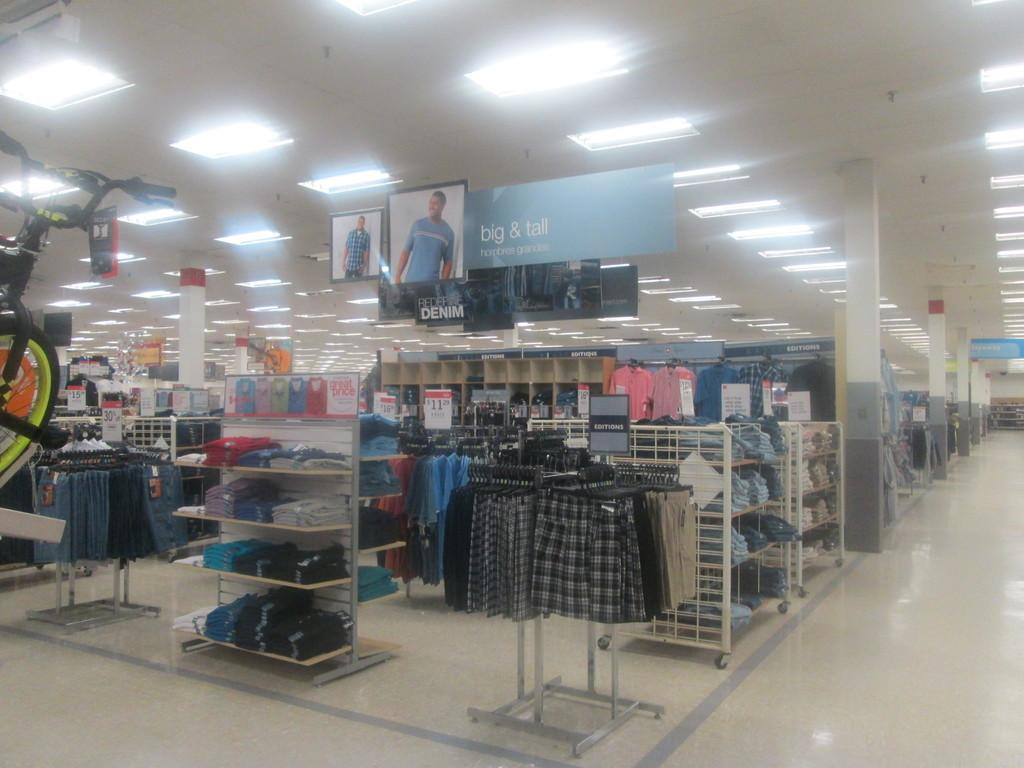<image>
Share a concise interpretation of the image provided. The big and tall section of a store that is brightly lit. 